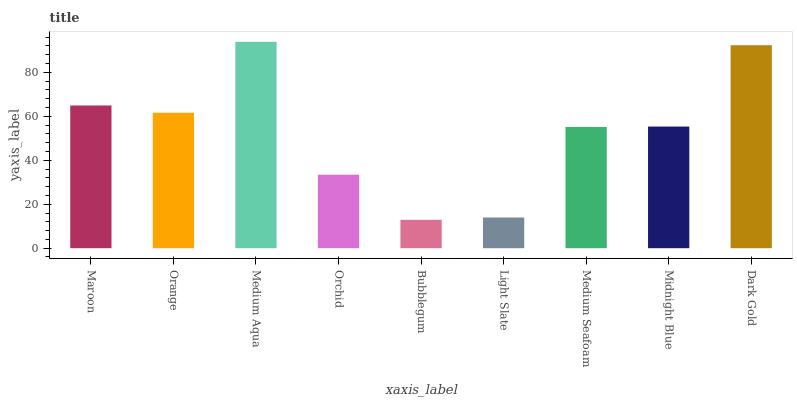Is Bubblegum the minimum?
Answer yes or no. Yes. Is Medium Aqua the maximum?
Answer yes or no. Yes. Is Orange the minimum?
Answer yes or no. No. Is Orange the maximum?
Answer yes or no. No. Is Maroon greater than Orange?
Answer yes or no. Yes. Is Orange less than Maroon?
Answer yes or no. Yes. Is Orange greater than Maroon?
Answer yes or no. No. Is Maroon less than Orange?
Answer yes or no. No. Is Midnight Blue the high median?
Answer yes or no. Yes. Is Midnight Blue the low median?
Answer yes or no. Yes. Is Maroon the high median?
Answer yes or no. No. Is Medium Aqua the low median?
Answer yes or no. No. 